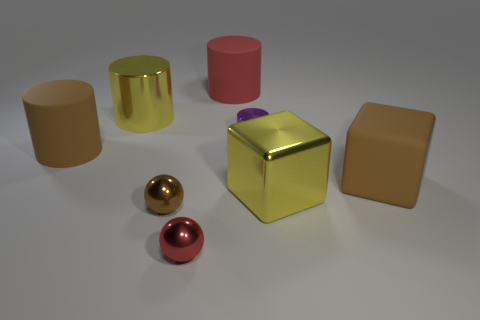Subtract all big brown cylinders. How many cylinders are left? 3 Subtract 1 cylinders. How many cylinders are left? 3 Add 2 small balls. How many objects exist? 10 Subtract all brown cylinders. How many cylinders are left? 3 Subtract all green cylinders. Subtract all green balls. How many cylinders are left? 4 Subtract all balls. How many objects are left? 6 Add 7 purple metallic cylinders. How many purple metallic cylinders are left? 8 Add 7 purple things. How many purple things exist? 8 Subtract 0 blue blocks. How many objects are left? 8 Subtract all yellow blocks. Subtract all yellow metal things. How many objects are left? 5 